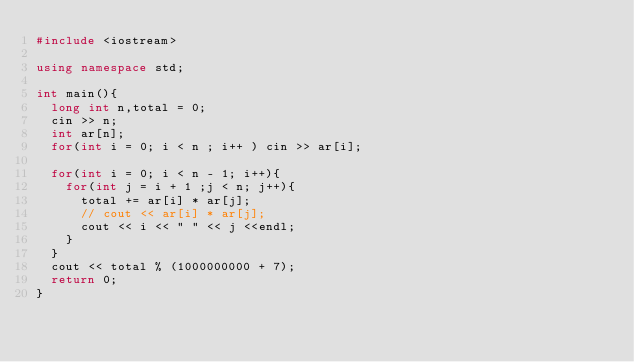<code> <loc_0><loc_0><loc_500><loc_500><_C++_>#include <iostream>

using namespace std;

int main(){
  long int n,total = 0;
  cin >> n;
  int ar[n];
  for(int i = 0; i < n ; i++ ) cin >> ar[i];

  for(int i = 0; i < n - 1; i++){
    for(int j = i + 1 ;j < n; j++){
      total += ar[i] * ar[j];
      // cout << ar[i] * ar[j];
      cout << i << " " << j <<endl;
    }
  }
  cout << total % (1000000000 + 7);
  return 0;
}
</code> 